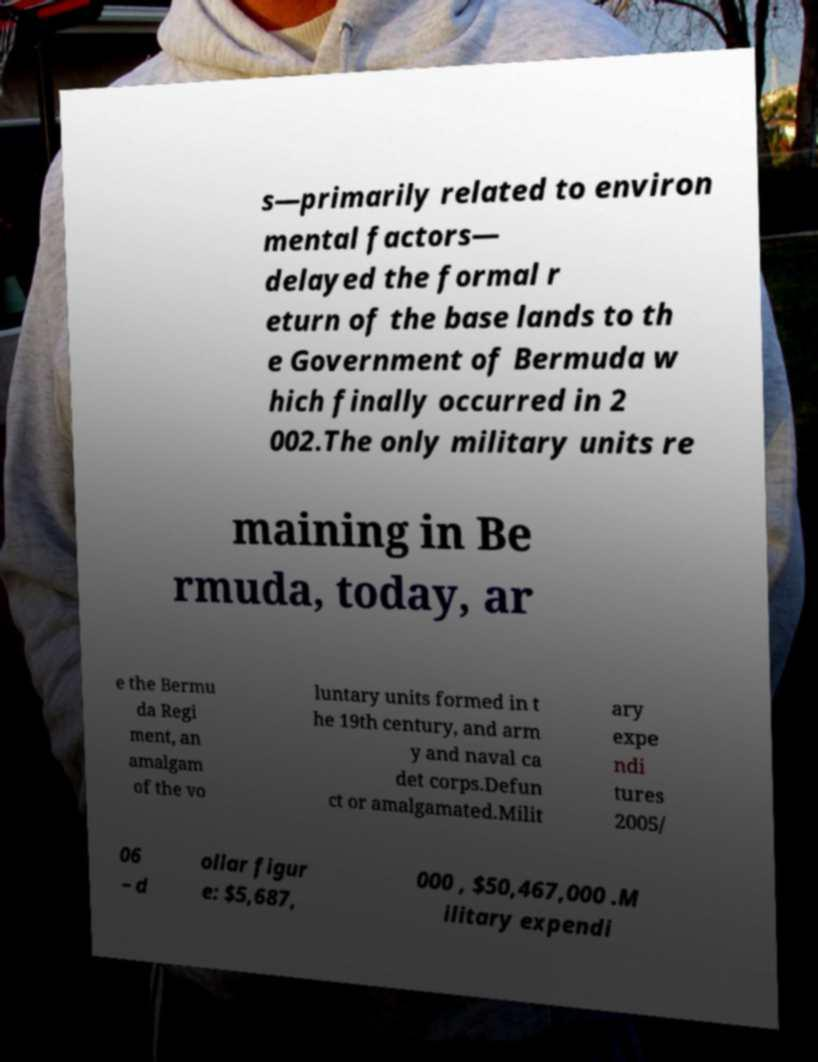Could you extract and type out the text from this image? s—primarily related to environ mental factors— delayed the formal r eturn of the base lands to th e Government of Bermuda w hich finally occurred in 2 002.The only military units re maining in Be rmuda, today, ar e the Bermu da Regi ment, an amalgam of the vo luntary units formed in t he 19th century, and arm y and naval ca det corps.Defun ct or amalgamated.Milit ary expe ndi tures 2005/ 06 – d ollar figur e: $5,687, 000 , $50,467,000 .M ilitary expendi 